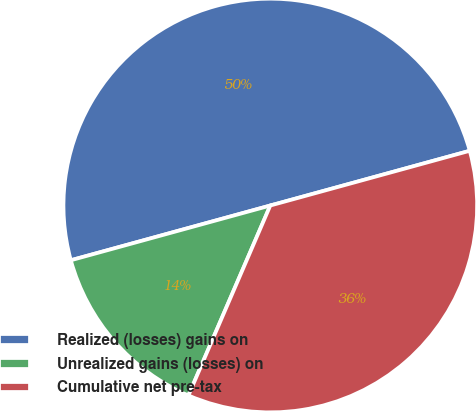Convert chart to OTSL. <chart><loc_0><loc_0><loc_500><loc_500><pie_chart><fcel>Realized (losses) gains on<fcel>Unrealized gains (losses) on<fcel>Cumulative net pre-tax<nl><fcel>50.0%<fcel>14.26%<fcel>35.74%<nl></chart> 